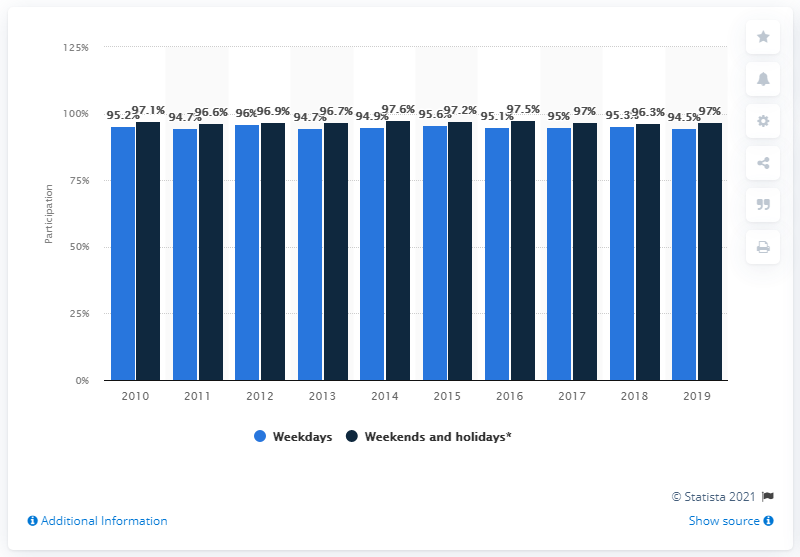Point out several critical features in this image. In 2010, the average percentage of the U.S. civilian population participated in sports and leisure activities. 